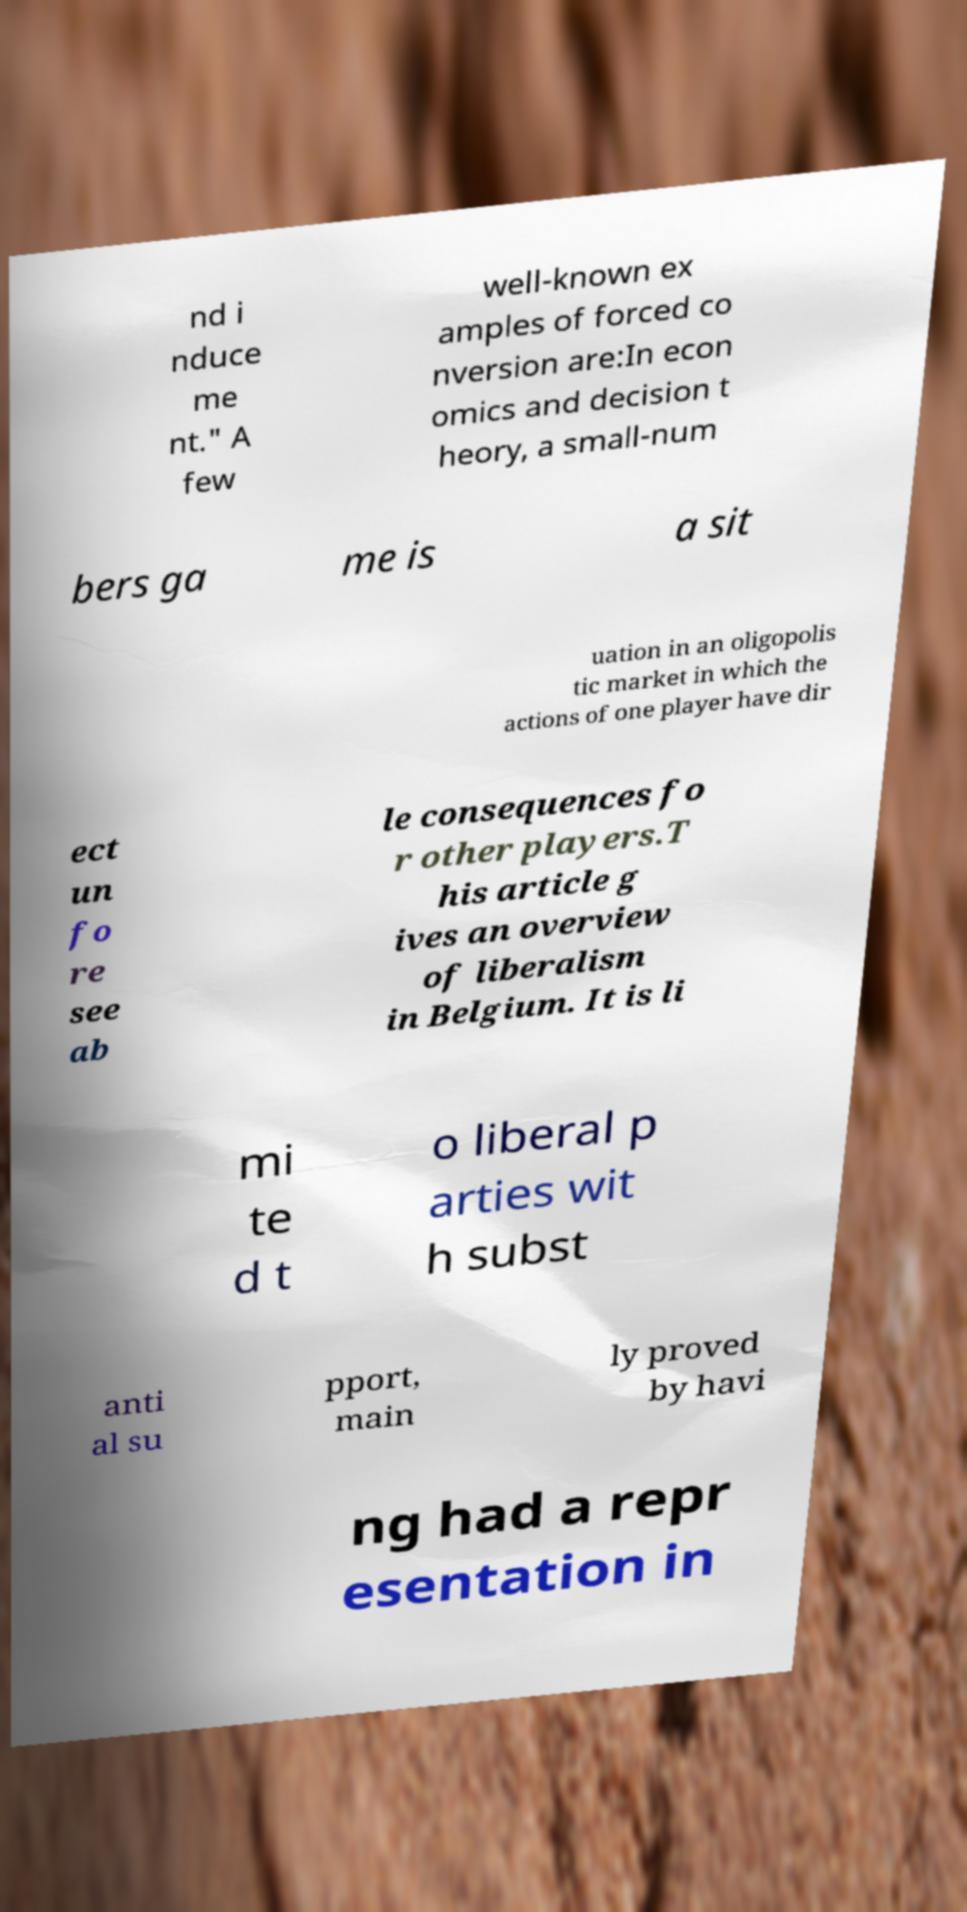Can you accurately transcribe the text from the provided image for me? nd i nduce me nt." A few well-known ex amples of forced co nversion are:In econ omics and decision t heory, a small-num bers ga me is a sit uation in an oligopolis tic market in which the actions of one player have dir ect un fo re see ab le consequences fo r other players.T his article g ives an overview of liberalism in Belgium. It is li mi te d t o liberal p arties wit h subst anti al su pport, main ly proved by havi ng had a repr esentation in 